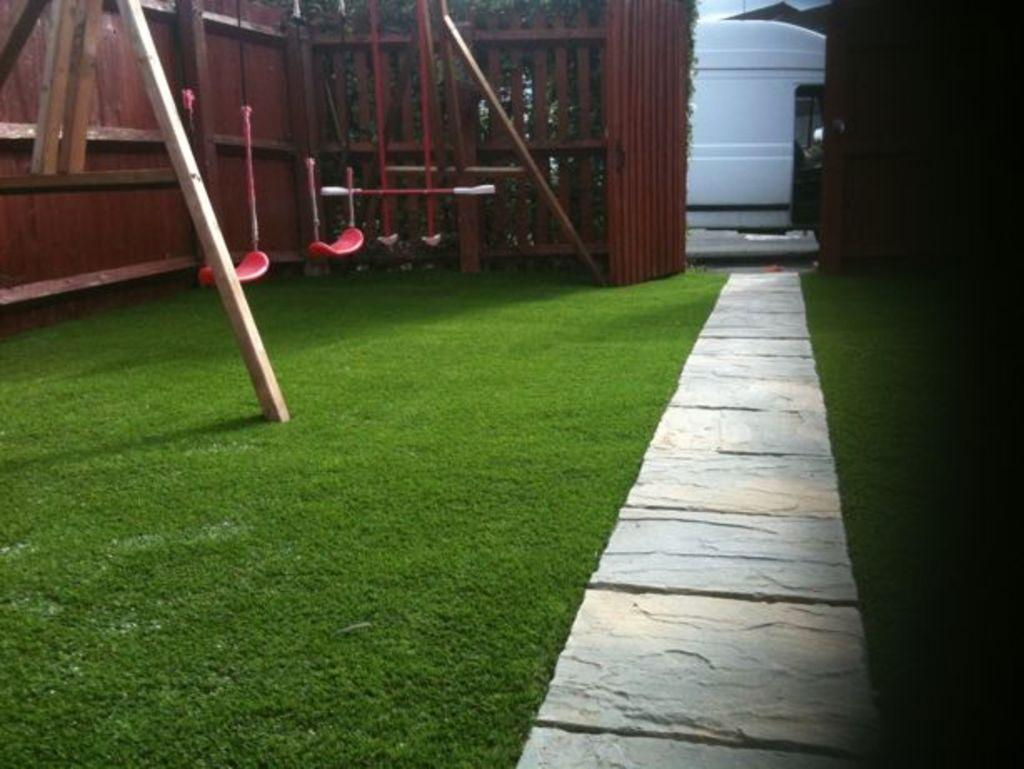What type of terrain is visible in the image? There is grassy land in the image. What feature allows for easy navigation through the grassy land? There is a pathway in the image. What type of recreational equipment can be seen in the image? There is a swing in the image. What type of barrier is present in the image? There is a wooden fence in the image. How can one enter or exit the grassy land? There is a gate in the image. What type of transportation is visible on the road behind the gate? There is a vehicle visible on the road behind the gate. What type of vest is being worn by the metal in the image? There is no vest or metal present in the image. 